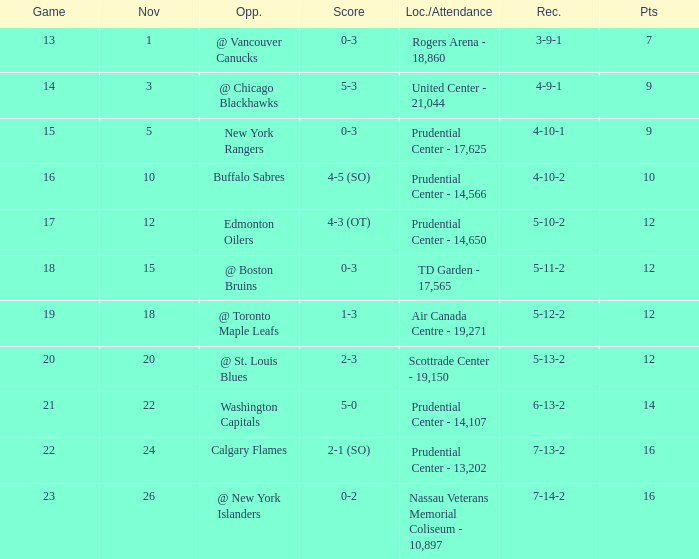What is the maximum number of points? 16.0. 